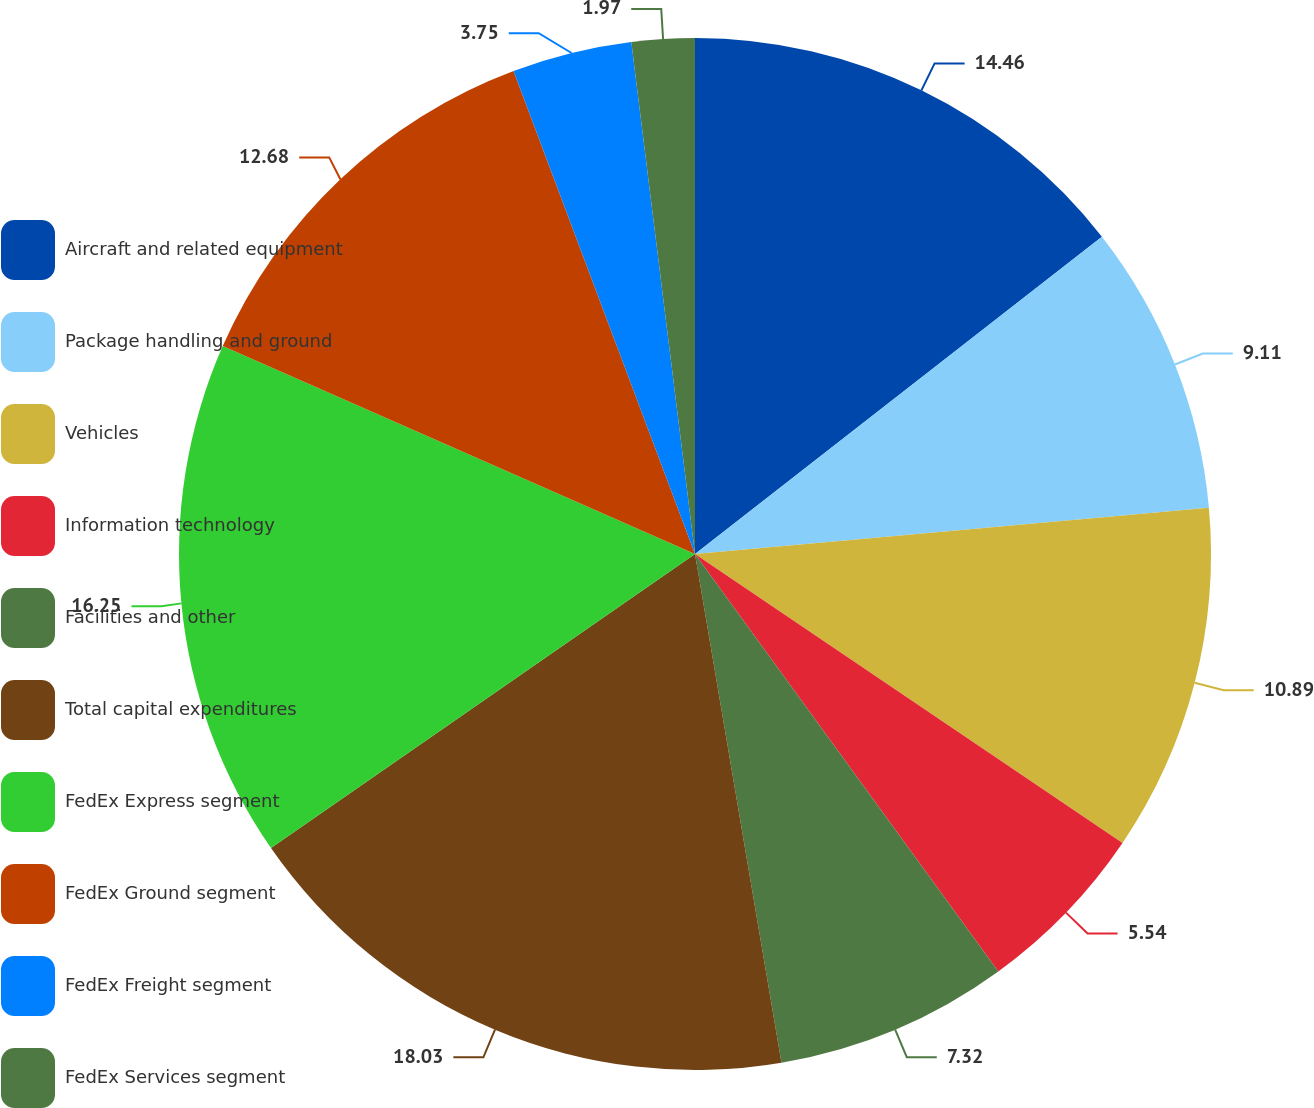<chart> <loc_0><loc_0><loc_500><loc_500><pie_chart><fcel>Aircraft and related equipment<fcel>Package handling and ground<fcel>Vehicles<fcel>Information technology<fcel>Facilities and other<fcel>Total capital expenditures<fcel>FedEx Express segment<fcel>FedEx Ground segment<fcel>FedEx Freight segment<fcel>FedEx Services segment<nl><fcel>14.46%<fcel>9.11%<fcel>10.89%<fcel>5.54%<fcel>7.32%<fcel>18.03%<fcel>16.25%<fcel>12.68%<fcel>3.75%<fcel>1.97%<nl></chart> 